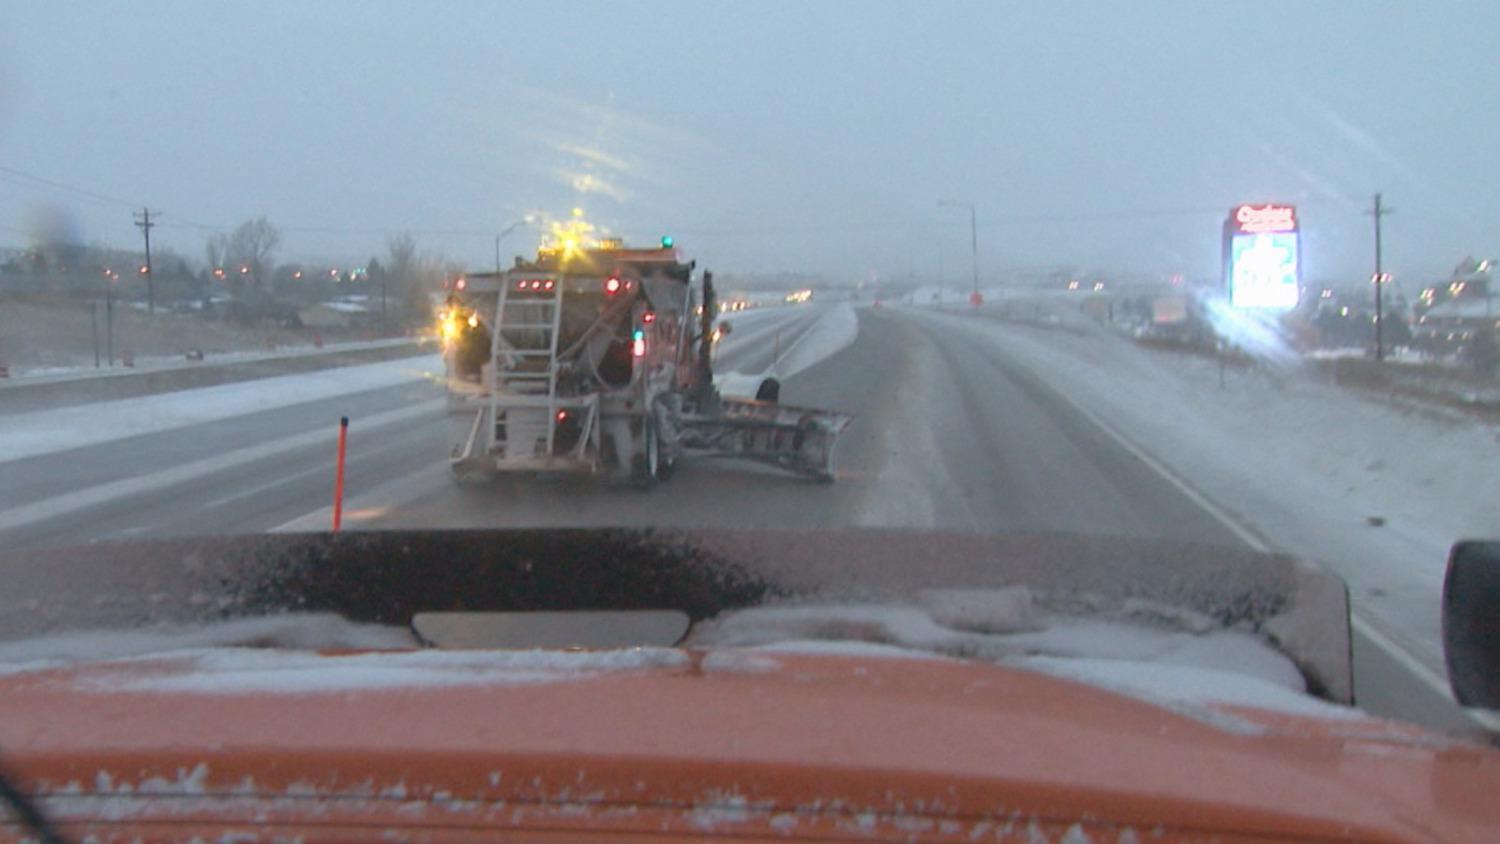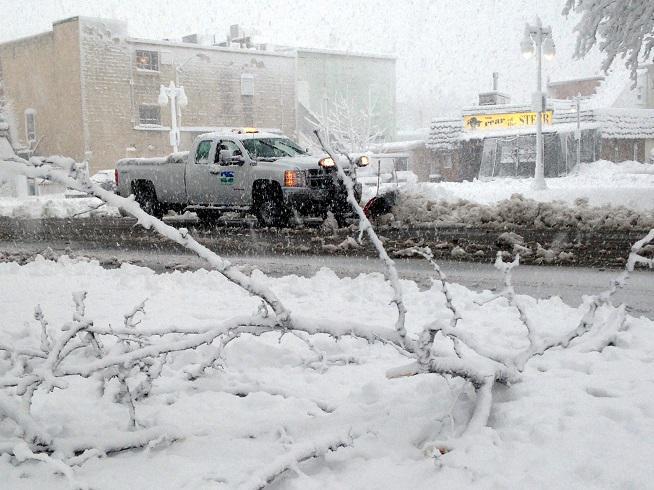The first image is the image on the left, the second image is the image on the right. Evaluate the accuracy of this statement regarding the images: "An image shows a truck with wheels instead of tank tracks heading rightward pushing snow, and the truck bed is bright yellow.". Is it true? Answer yes or no. No. The first image is the image on the left, the second image is the image on the right. Assess this claim about the two images: "The yellow truck is pushing the snow in the image on the left.". Correct or not? Answer yes or no. No. 